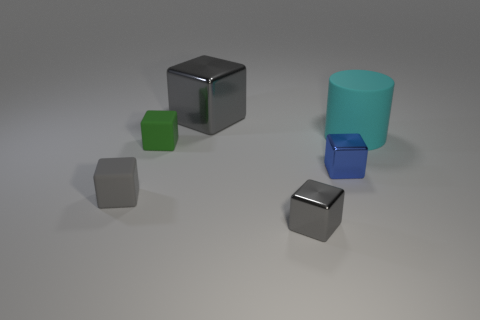How many gray blocks must be subtracted to get 1 gray blocks? 2 Subtract all yellow spheres. How many gray blocks are left? 3 Subtract all yellow cylinders. Subtract all green blocks. How many cylinders are left? 1 Add 3 large gray things. How many objects exist? 9 Subtract all blocks. How many objects are left? 1 Subtract 0 purple cylinders. How many objects are left? 6 Subtract all tiny green cubes. Subtract all large cyan metal blocks. How many objects are left? 5 Add 2 tiny green blocks. How many tiny green blocks are left? 3 Add 2 metal objects. How many metal objects exist? 5 